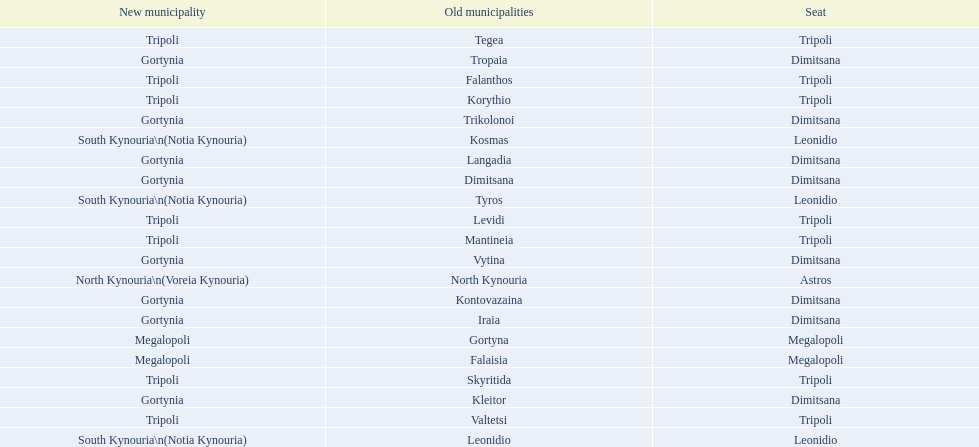What is the new municipality of tyros? South Kynouria. 